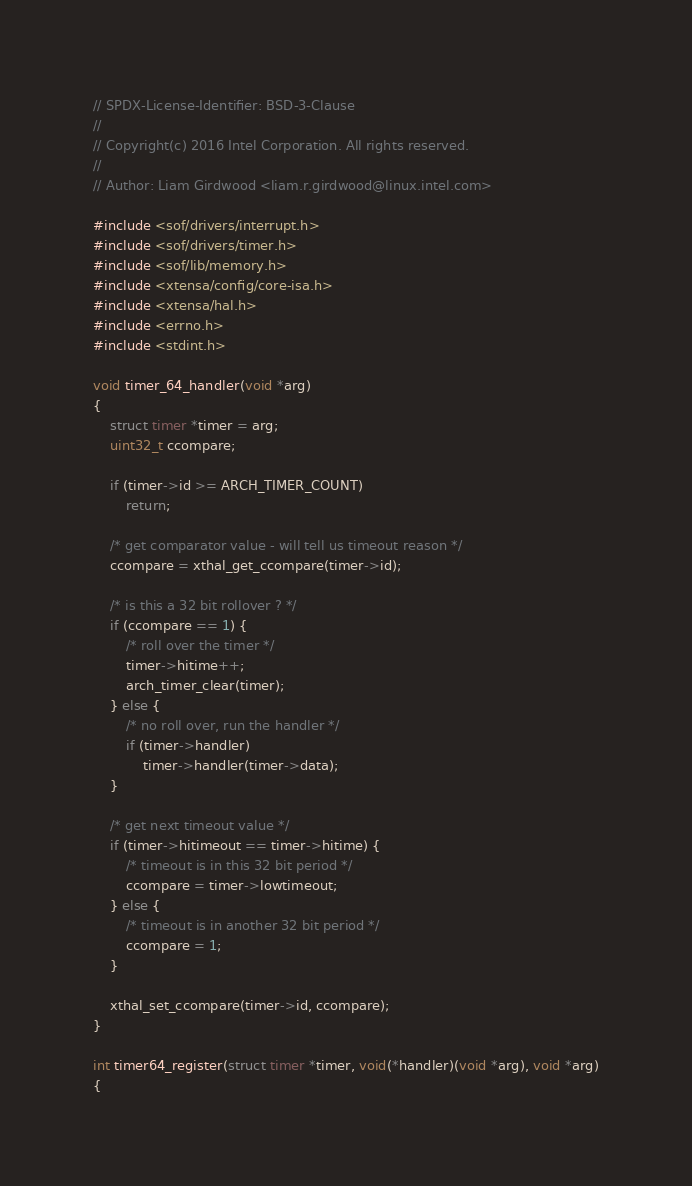<code> <loc_0><loc_0><loc_500><loc_500><_C_>// SPDX-License-Identifier: BSD-3-Clause
//
// Copyright(c) 2016 Intel Corporation. All rights reserved.
//
// Author: Liam Girdwood <liam.r.girdwood@linux.intel.com>

#include <sof/drivers/interrupt.h>
#include <sof/drivers/timer.h>
#include <sof/lib/memory.h>
#include <xtensa/config/core-isa.h>
#include <xtensa/hal.h>
#include <errno.h>
#include <stdint.h>

void timer_64_handler(void *arg)
{
	struct timer *timer = arg;
	uint32_t ccompare;

	if (timer->id >= ARCH_TIMER_COUNT)
		return;

	/* get comparator value - will tell us timeout reason */
	ccompare = xthal_get_ccompare(timer->id);

	/* is this a 32 bit rollover ? */
	if (ccompare == 1) {
		/* roll over the timer */
		timer->hitime++;
		arch_timer_clear(timer);
	} else {
		/* no roll over, run the handler */
		if (timer->handler)
			timer->handler(timer->data);
	}

	/* get next timeout value */
	if (timer->hitimeout == timer->hitime) {
		/* timeout is in this 32 bit period */
		ccompare = timer->lowtimeout;
	} else {
		/* timeout is in another 32 bit period */
		ccompare = 1;
	}

	xthal_set_ccompare(timer->id, ccompare);
}

int timer64_register(struct timer *timer, void(*handler)(void *arg), void *arg)
{</code> 